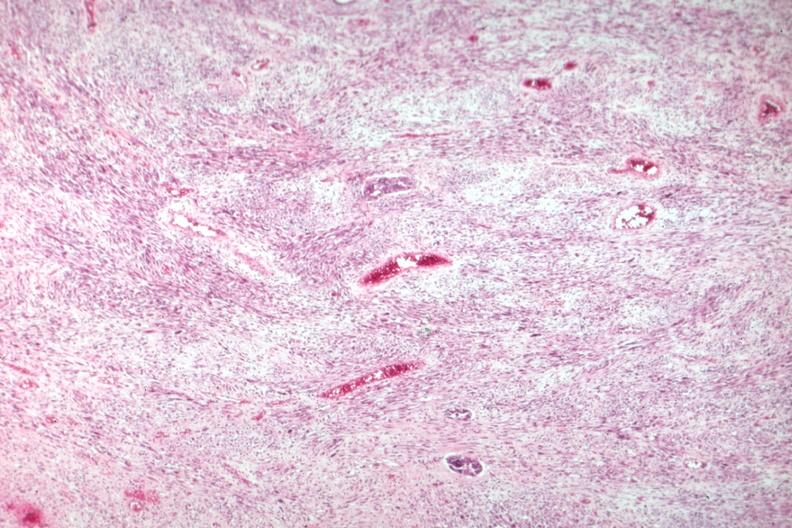s female reproductive present?
Answer the question using a single word or phrase. Yes 